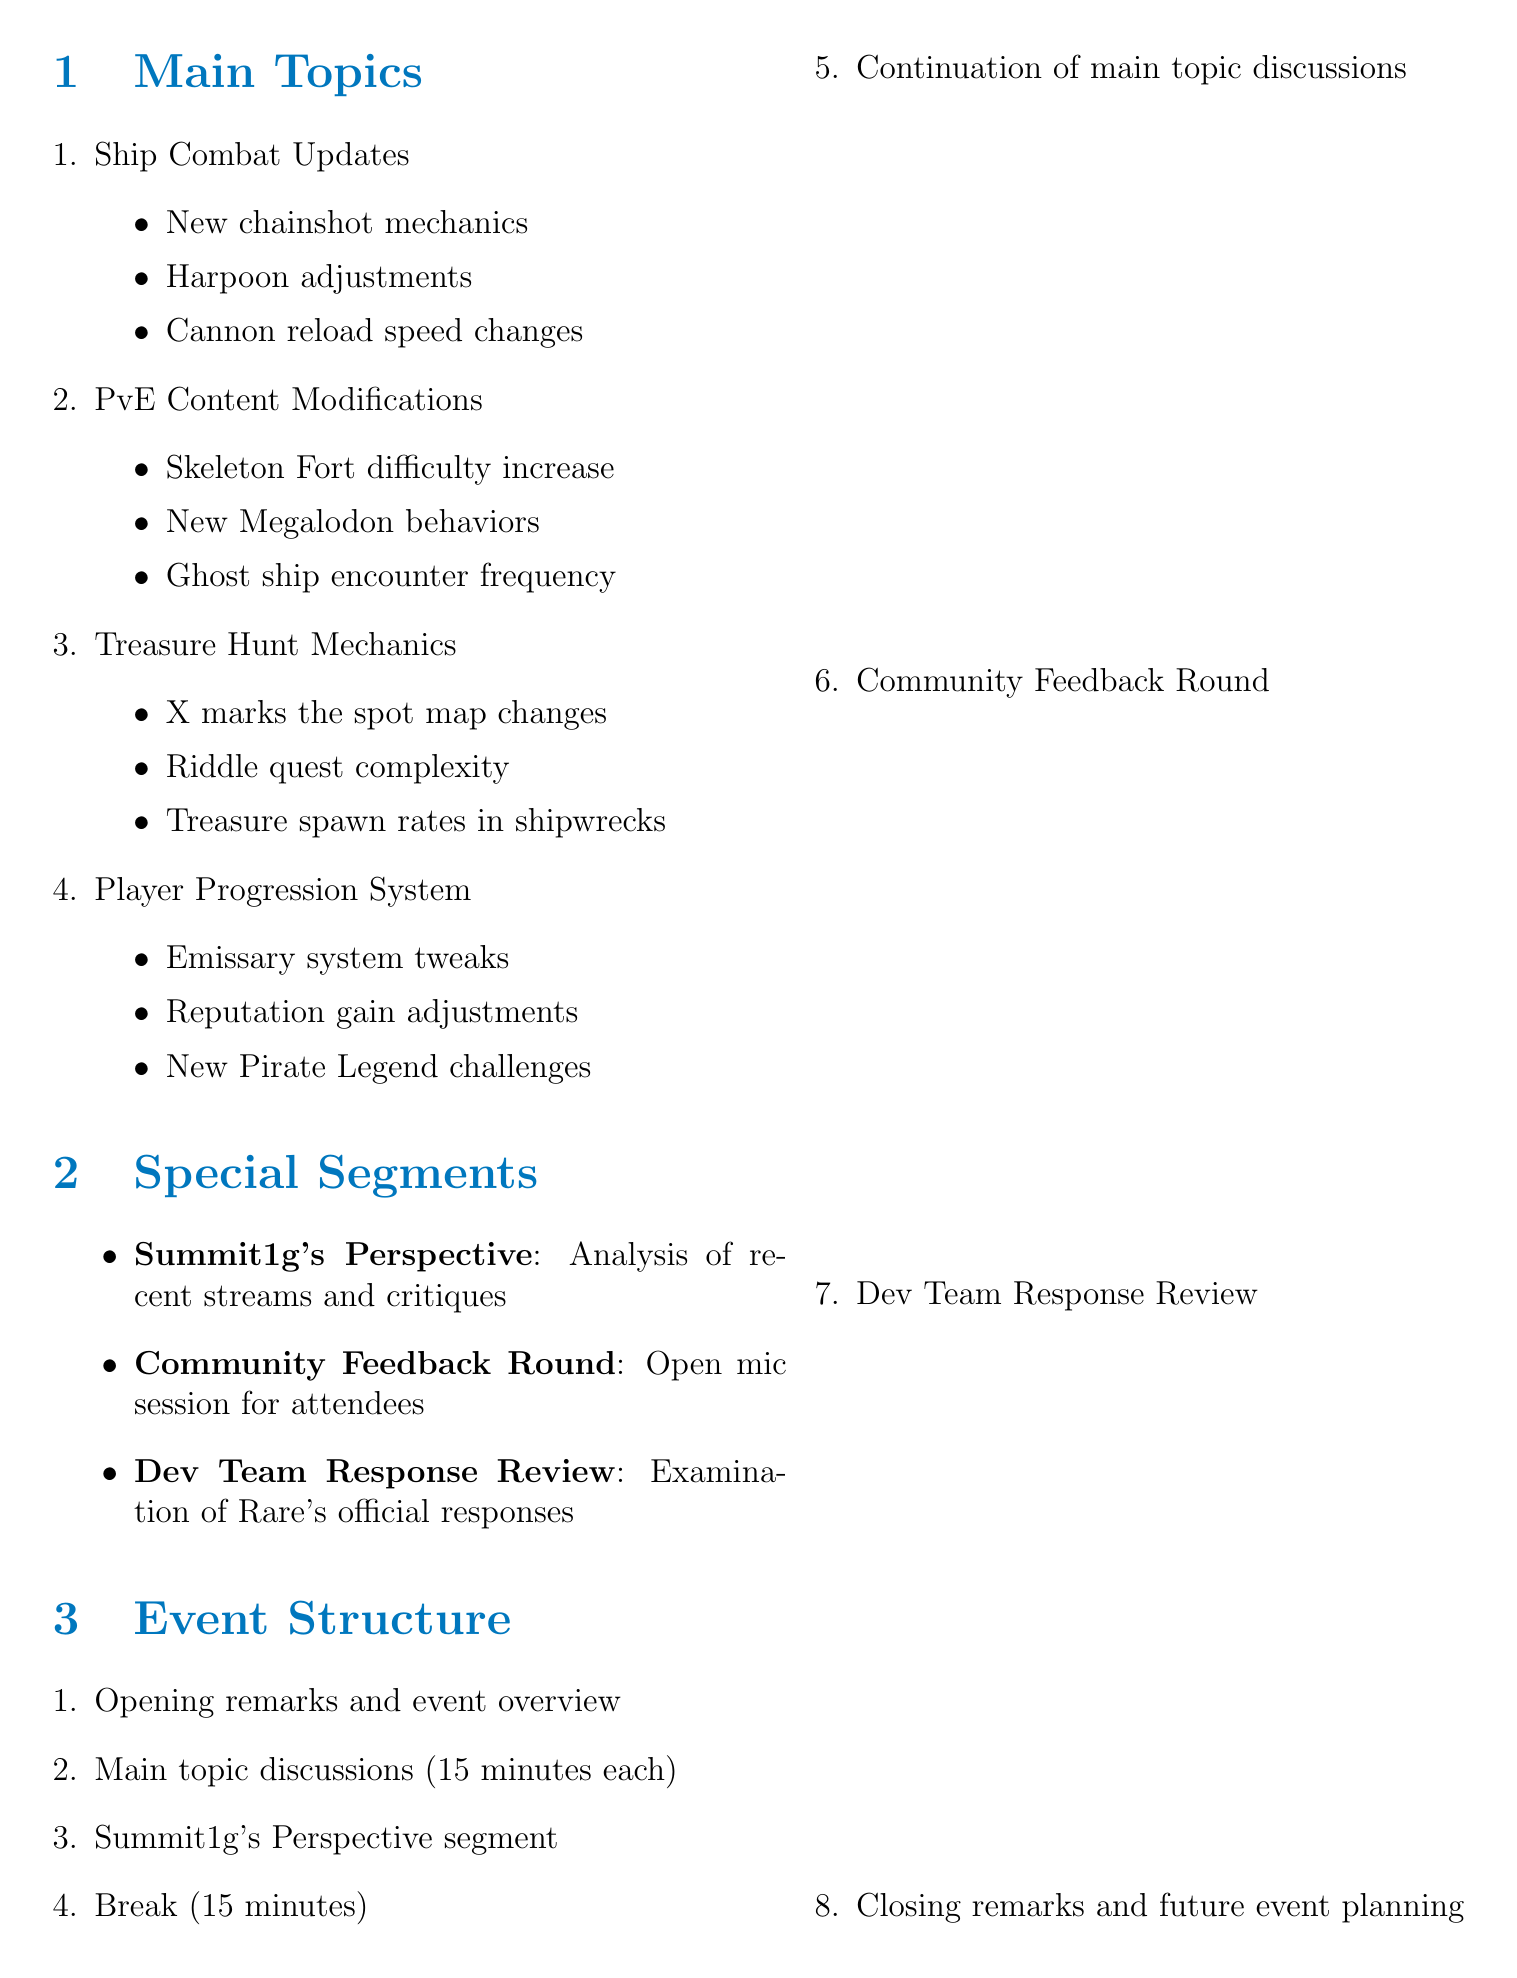What is the event title? The event title is specified at the beginning of the document.
Answer: Sea of Thieves Mechanics Overhaul: Community Critique How many main topics are discussed? The number of main topics is mentioned in the list under Main Topics.
Answer: Four What is one of the subtopics under Ship Combat Updates? The subtopics under Ship Combat Updates are listed; one of them can be found in the document.
Answer: New chainshot mechanics Who is a suggested speaker for the event? The suggested speakers are listed in the corresponding section; any name can be provided as an answer.
Answer: Captain Falcore What is the duration of the main topic discussions? The duration is specified in the event structure section.
Answer: 15 minutes What is one community engagement idea mentioned? Community engagement ideas are listed in the document; one of the options can be found easily.
Answer: Live polls during discussions What is the purpose of the Community Feedback Round? The purpose is described directly in the section about Special Segments.
Answer: Open mic session for attendees Who will provide analysis in the Summit1g's Perspective segment? The segment description indicates who provides the analysis.
Answer: Summit1g 